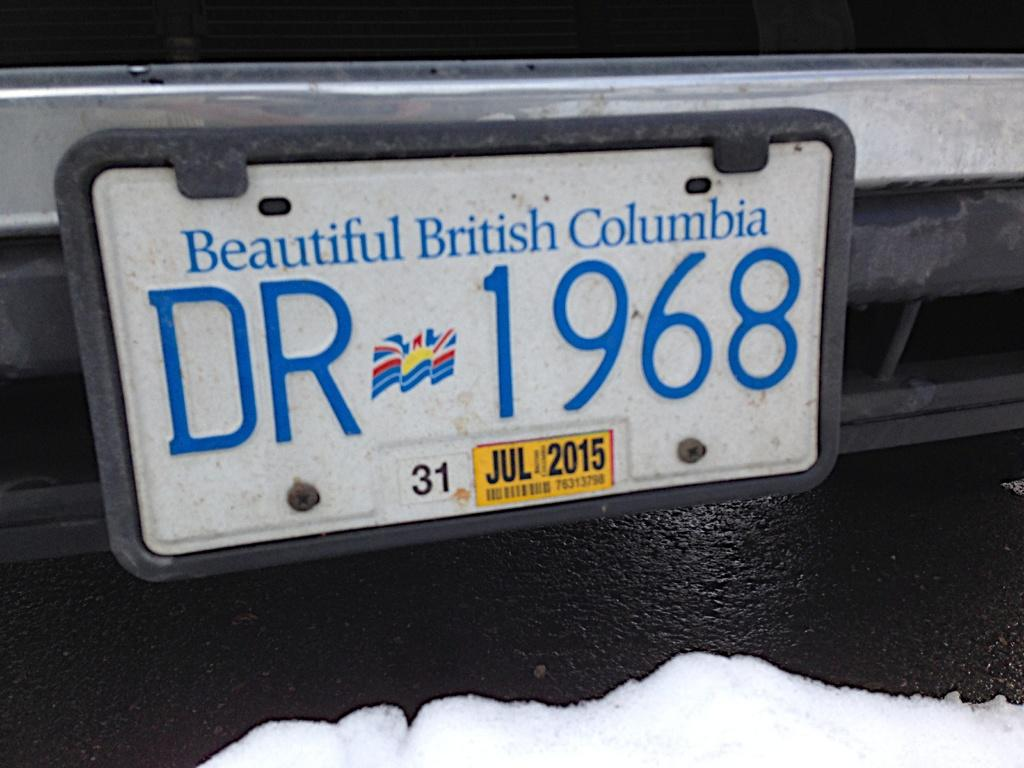<image>
Give a short and clear explanation of the subsequent image. A tag with Beautiful British Columbia and number DR 1968 on tag plate. 